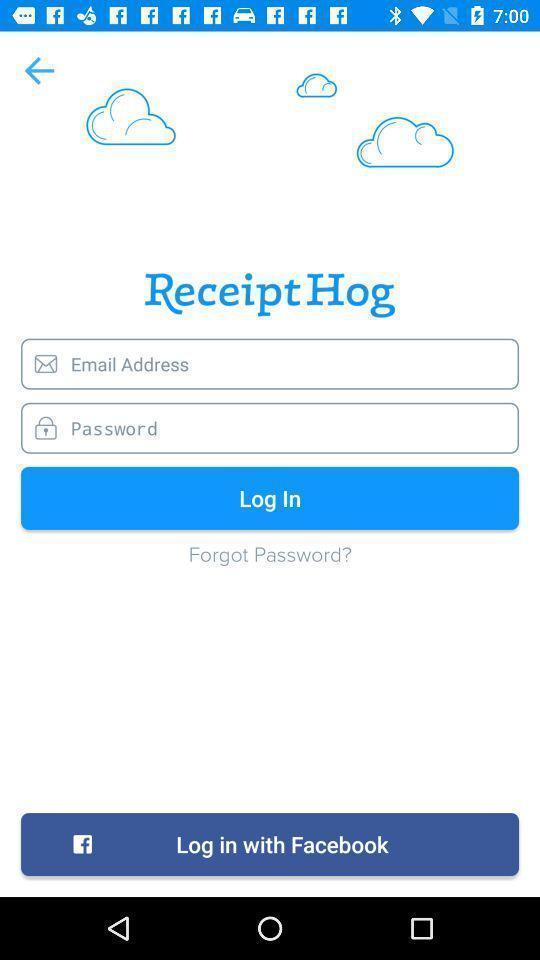Provide a detailed account of this screenshot. Page displaying to enter login credentials. 